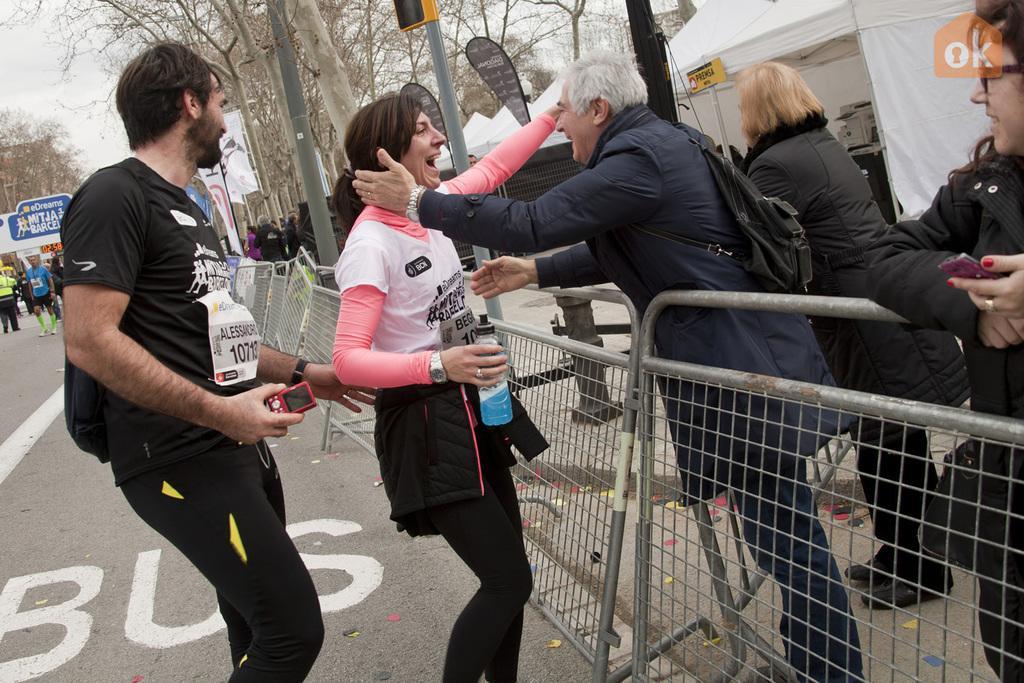Describe this image in one or two sentences. In the picture I can see people among them some are standing and some are walking on the road. The people in the front are smiling. In the background I can see a fence, poles, trees, the sky and some other objects on the ground. 